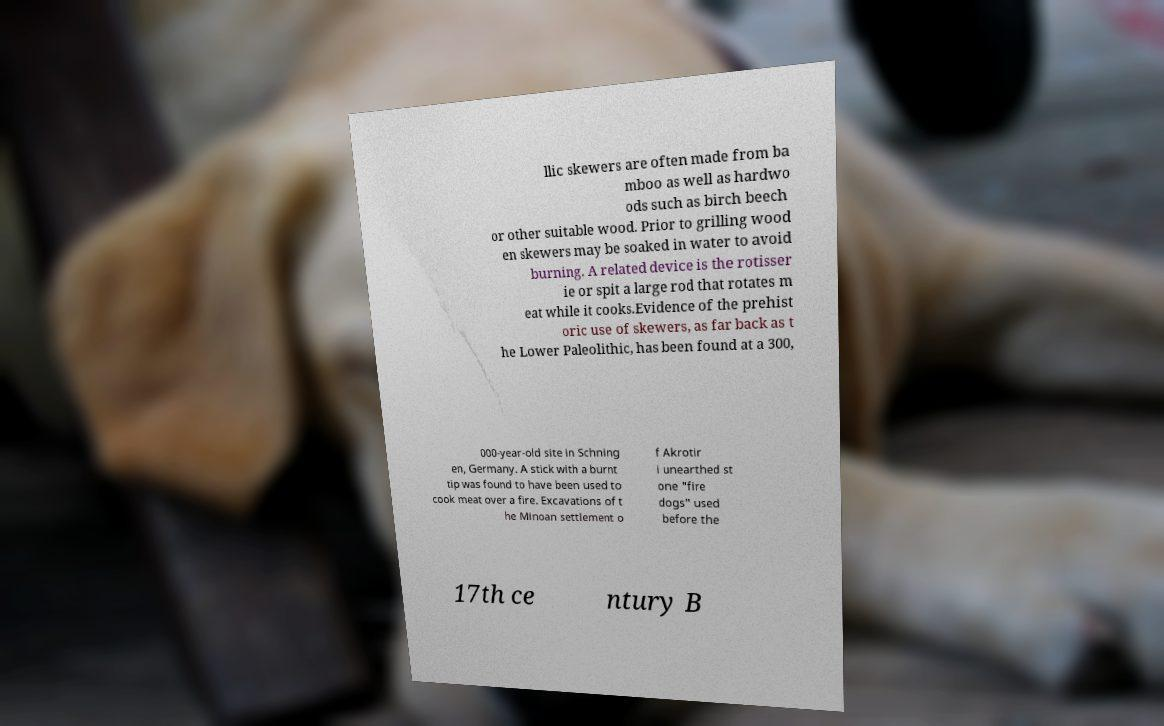Please read and relay the text visible in this image. What does it say? llic skewers are often made from ba mboo as well as hardwo ods such as birch beech or other suitable wood. Prior to grilling wood en skewers may be soaked in water to avoid burning. A related device is the rotisser ie or spit a large rod that rotates m eat while it cooks.Evidence of the prehist oric use of skewers, as far back as t he Lower Paleolithic, has been found at a 300, 000-year-old site in Schning en, Germany. A stick with a burnt tip was found to have been used to cook meat over a fire. Excavations of t he Minoan settlement o f Akrotir i unearthed st one "fire dogs" used before the 17th ce ntury B 